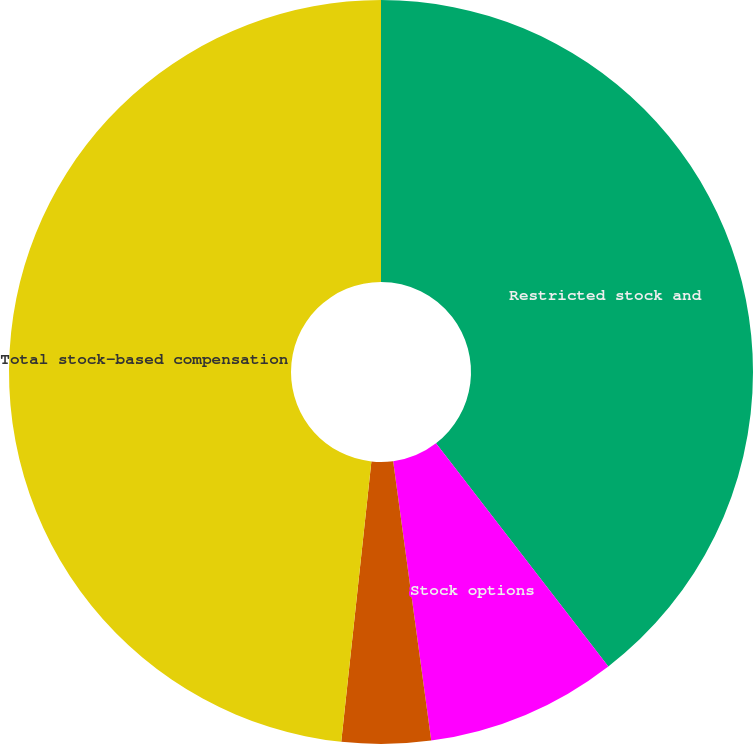Convert chart. <chart><loc_0><loc_0><loc_500><loc_500><pie_chart><fcel>Restricted stock and<fcel>Stock options<fcel>Restricted stock<fcel>Total stock-based compensation<nl><fcel>39.54%<fcel>8.31%<fcel>3.86%<fcel>48.3%<nl></chart> 